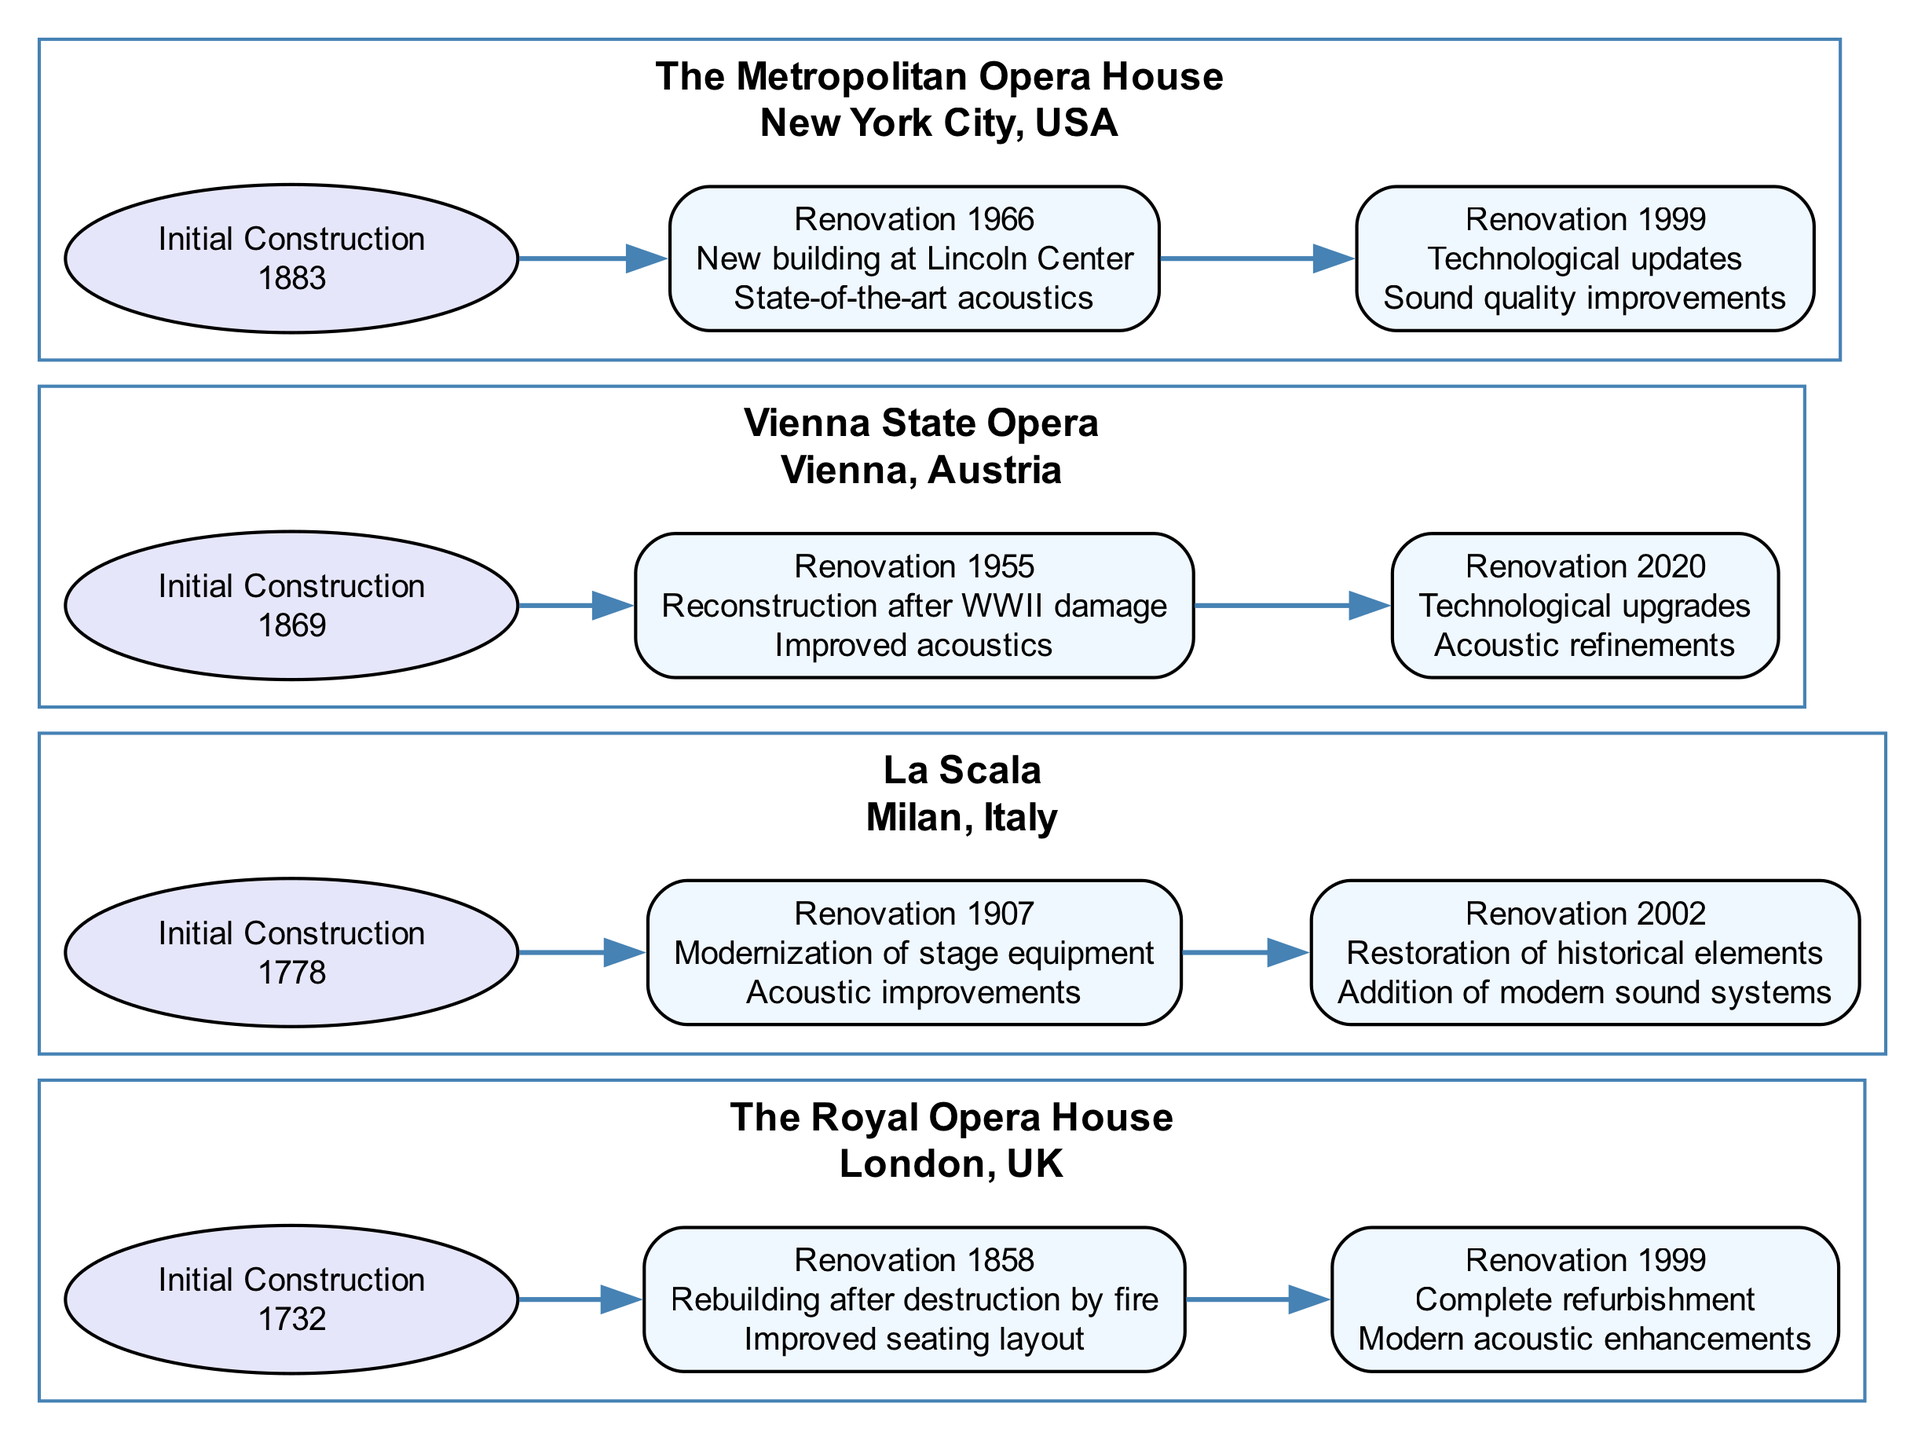What year was the initial construction of La Scala? The initial construction year of La Scala is directly stated in the diagram, under the subgraph for La Scala, which shows that it was constructed in 1778.
Answer: 1778 Which theater underwent a renovation in 1907? By examining the renovation timelines for each theater, it is clear that La Scala had a major renovation in 1907 as indicated in its renovation list.
Answer: La Scala What improvements were made in the 2020 renovation of the Vienna State Opera? The improvements made during the 2020 renovation of the Vienna State Opera can be found in the diagram next to the 2020 node, listing "Technological upgrades" and "Acoustic refinements."
Answer: Technological upgrades, Acoustic refinements How many major renovations did The Metropolitan Opera House have? Counting the renovation nodes under The Metropolitan Opera House in the diagram reveals two major renovations: one in 1966 and another in 1999.
Answer: 2 Which theater has the improvement list that includes "Improved acoustics"? To determine which theater has the improvement of "Improved acoustics," I searched through the major renovations of each theater and found this improvement listed under the Vienna State Opera's renovation in 1955.
Answer: Vienna State Opera What is the location of the Royal Opera House? The location of the Royal Opera House is identified within its subgraph in the diagram, which states "London, UK."
Answer: London, UK What was the purpose of the 1999 renovation of the Royal Opera House? Referring to the improvements listed in the 1999 renovation node for the Royal Opera House, the purposes were a "Complete refurbishment" and "Modern acoustic enhancements."
Answer: Complete refurbishment, Modern acoustic enhancements Which theater's major renovations include "State-of-the-art acoustics"? By checking the major renovations listed in the diagram for each theater, it shows that the Metropolitan Opera House had this improvement in its 1966 renovation.
Answer: The Metropolitan Opera House During which renovation did La Scala modernize its stage equipment? The modernization of stage equipment at La Scala occurred during its renovation year in 1907, as stated in the improvements for that year in the diagram.
Answer: 1907 